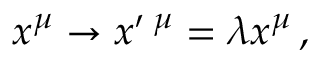<formula> <loc_0><loc_0><loc_500><loc_500>x ^ { \mu } \rightarrow x ^ { \prime } \, ^ { \mu } = \lambda x ^ { \mu } \, ,</formula> 